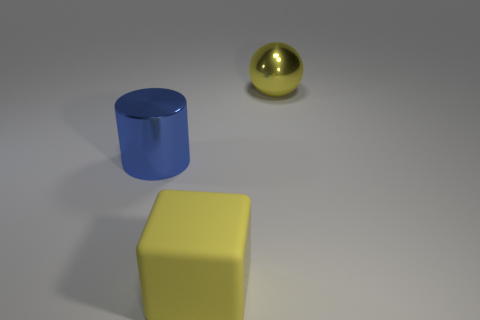Add 3 brown metal spheres. How many objects exist? 6 Subtract all cylinders. How many objects are left? 2 Add 2 balls. How many balls are left? 3 Add 2 large blue metal cylinders. How many large blue metal cylinders exist? 3 Subtract 0 brown cylinders. How many objects are left? 3 Subtract all big blue shiny objects. Subtract all cylinders. How many objects are left? 1 